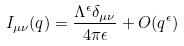<formula> <loc_0><loc_0><loc_500><loc_500>I _ { \mu \nu } ( q ) = \frac { \Lambda ^ { \epsilon } \delta _ { \mu \nu } } { 4 \pi \epsilon } + O ( q ^ { \epsilon } )</formula> 